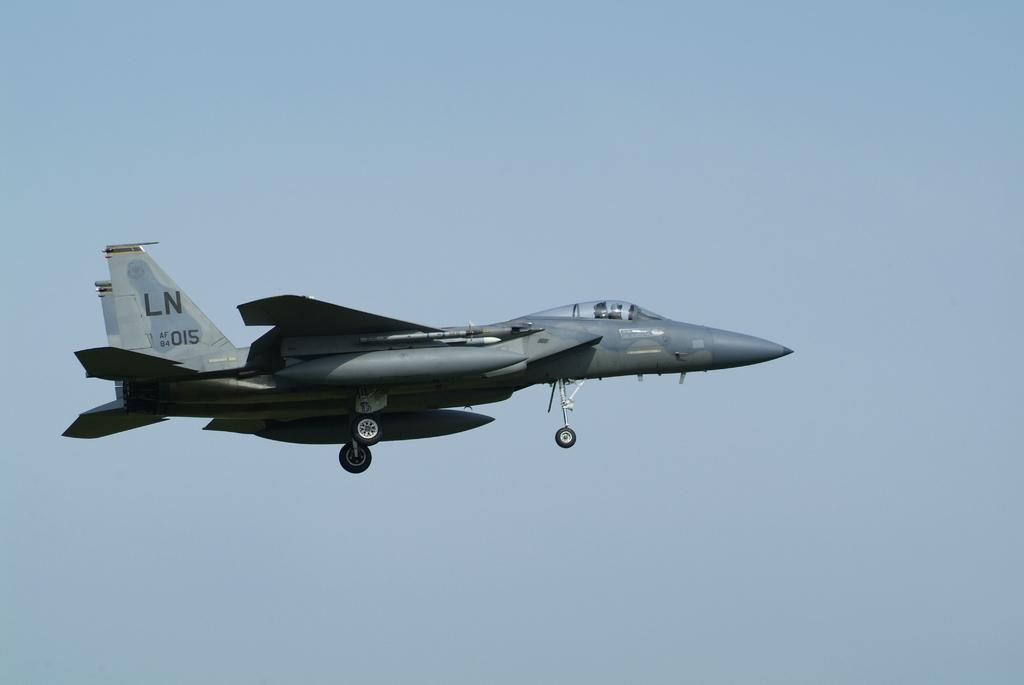What is the main subject of subject of the picture? The main subject of the picture is an airplane. What is the airplane doing in the picture? The airplane is flying in the air. Where is the airplane located in the picture? The airplane is in the middle of the picture. What can be seen in the background of the picture? There is sky visible in the background of the picture. Can you tell me how many kitties are playing with a test in the image? There are no kitties or tests present in the image; it features an airplane flying in the sky. What is the airplane's hope for the future in the image? The image does not convey any information about the airplane's hopes for the future. 